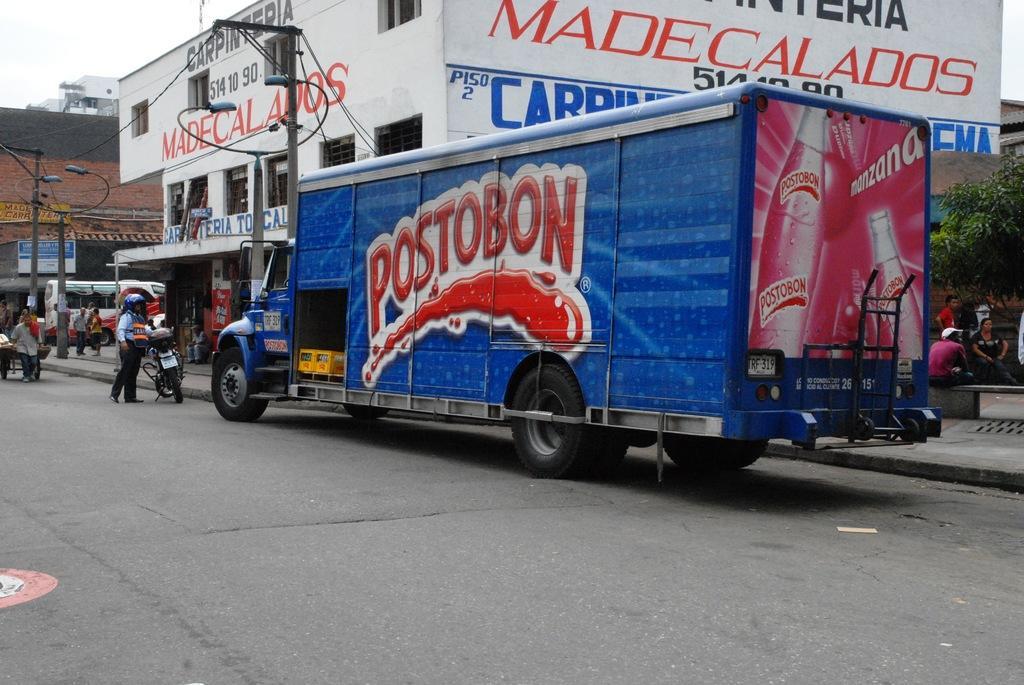How would you summarize this image in a sentence or two? In this image I can see a road , on the road there is a vehicle visible , man, bi-cycle ,cart vehicle , persons visible , on the right side tree, persons hoarding board , building in the middle , in front of the building vehicle, persons ,pole, power line cable, in the top left there is the sky visible. on the left side there is another building, vehicles. 